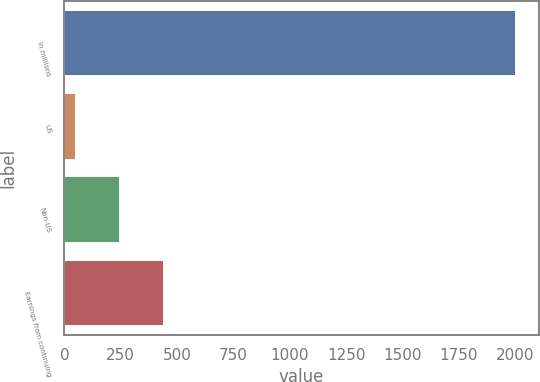Convert chart to OTSL. <chart><loc_0><loc_0><loc_500><loc_500><bar_chart><fcel>In millions<fcel>US<fcel>Non-US<fcel>Earnings from continuing<nl><fcel>2005<fcel>53<fcel>248.2<fcel>443.4<nl></chart> 